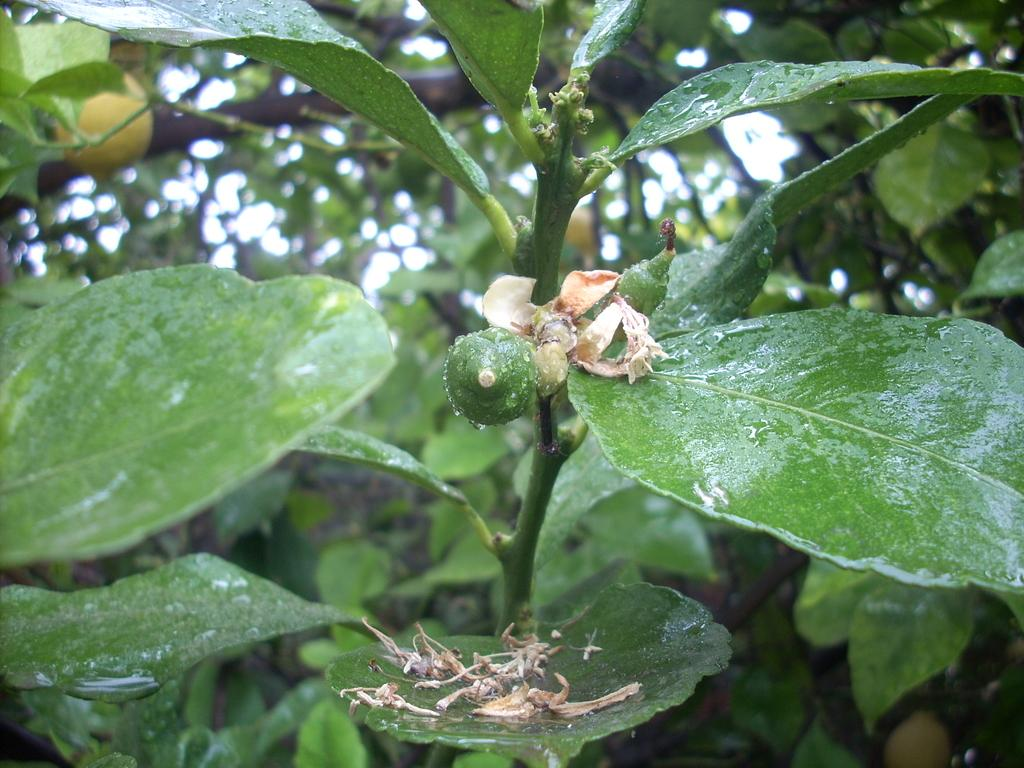What is located in the foreground of the image? There is a plant in the foreground of the image. What specific features can be observed on the plant? The plant has a flower and a bud. What can be seen in the background of the image? There is a tree in the background of the image. What additional detail can be observed about the tree? There is a fruit visible on the tree. What invention is being demonstrated in the image? There is no invention being demonstrated in the image; it features a plant with a flower and a bud, as well as a tree with a fruit. What type of spark can be seen coming from the plant in the image? There is no spark visible in the image; it is a still image of a plant and a tree. 